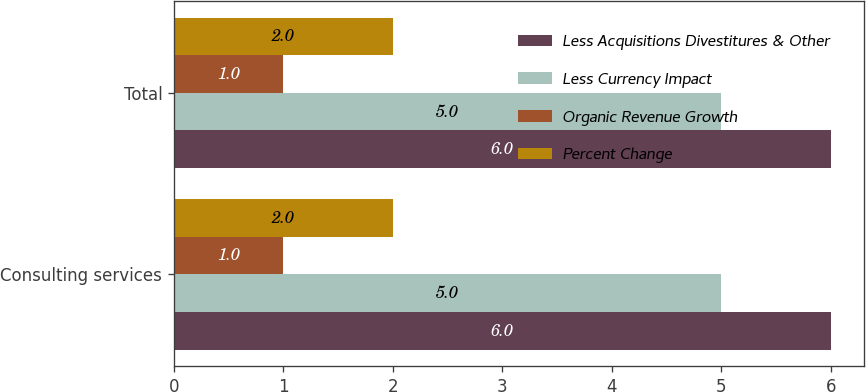Convert chart. <chart><loc_0><loc_0><loc_500><loc_500><stacked_bar_chart><ecel><fcel>Consulting services<fcel>Total<nl><fcel>Less Acquisitions Divestitures & Other<fcel>6<fcel>6<nl><fcel>Less Currency Impact<fcel>5<fcel>5<nl><fcel>Organic Revenue Growth<fcel>1<fcel>1<nl><fcel>Percent Change<fcel>2<fcel>2<nl></chart> 